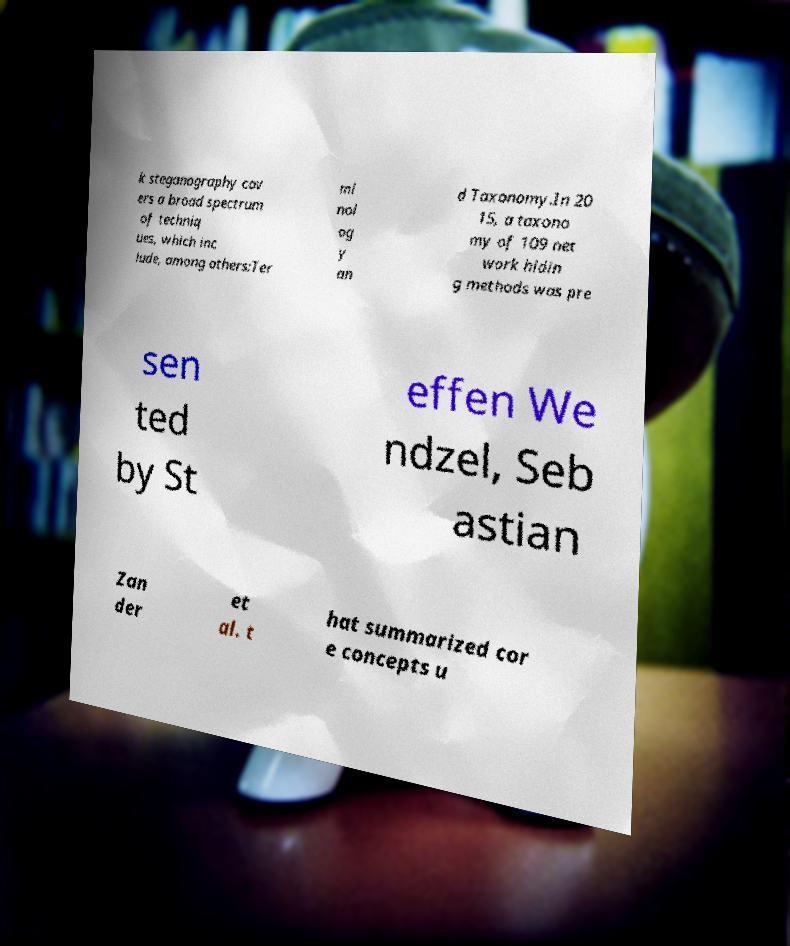Could you assist in decoding the text presented in this image and type it out clearly? k steganography cov ers a broad spectrum of techniq ues, which inc lude, among others:Ter mi nol og y an d Taxonomy.In 20 15, a taxono my of 109 net work hidin g methods was pre sen ted by St effen We ndzel, Seb astian Zan der et al. t hat summarized cor e concepts u 